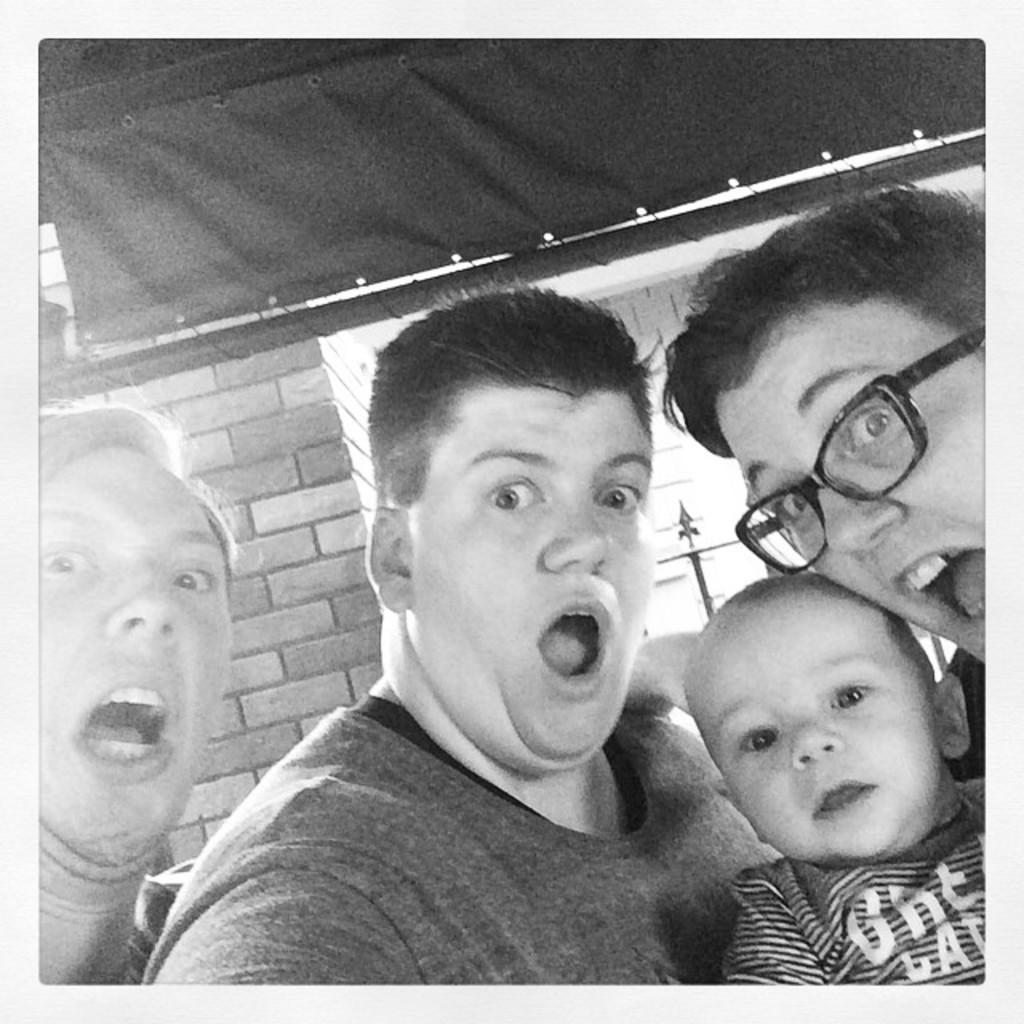What is the color scheme of the image? The image is black and white. What can be seen in the image besides the color scheme? There are people, a brick wall, rods, and cloth in the image. How many bubbles can be seen in the image? There are no bubbles present in the image. What type of balls are visible in the image? There are no balls present in the image. 